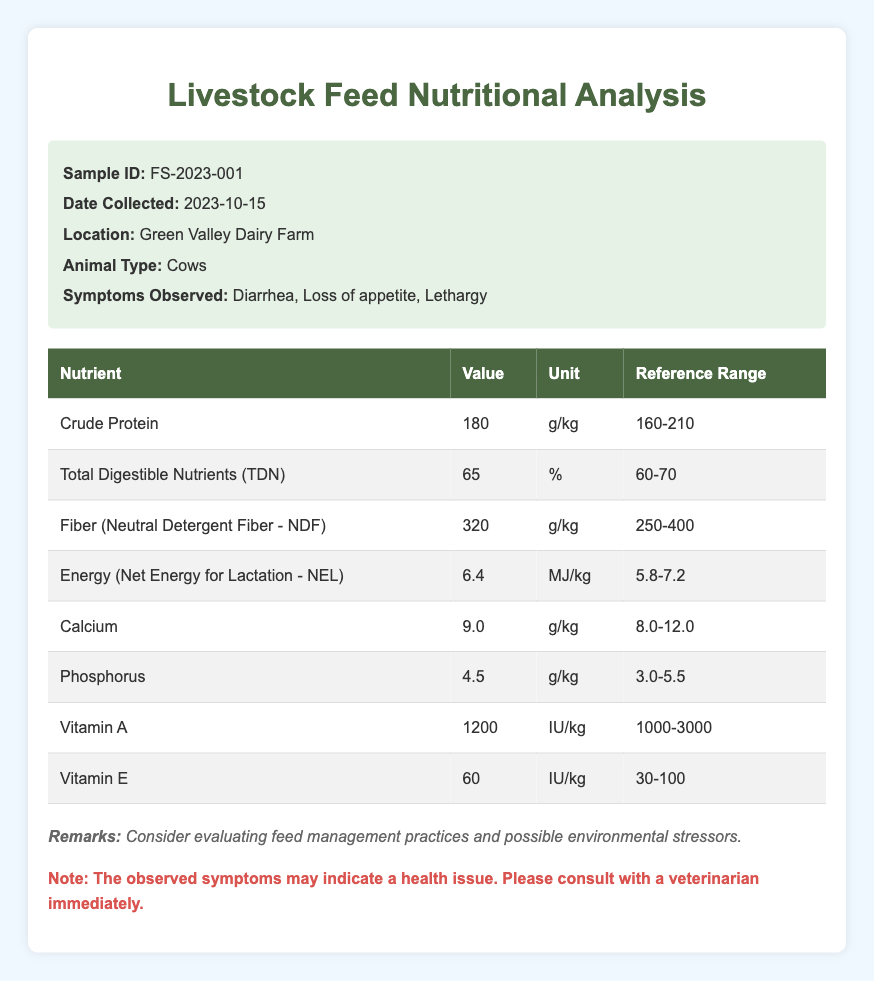What is the Crude Protein value in the feed sample? The table indicates that the Crude Protein value for the feed sample is listed under the "Nutritional Components," specifically for the nutrient "Crude Protein," where the value is 180 g/kg.
Answer: 180 g/kg What are the symptoms observed in the cows? According to the sample information section, the observed symptoms for the cows include "Diarrhea," "Loss of appetite," and "Lethargy."
Answer: Diarrhea, Loss of appetite, Lethargy Is the Total Digestible Nutrients (TDN) value within the acceptable reference range? The TDN value is given as 65%, which lies within the reference range of 60-70%. Since 65% is between the lower limit of 60% and the upper limit of 70%, it is indeed acceptable.
Answer: Yes What nutrient has the highest value in the analysis? To find the nutrient with the highest value, we need to compare all the values listed: Crude Protein 180 g/kg, TDN 65%, Fiber 320 g/kg, NEL 6.4 MJ/kg, Calcium 9.0 g/kg, Phosphorus 4.5 g/kg, Vitamin A 1200 IU/kg, and Vitamin E 60 IU/kg. Among these, Crude Protein, Fiber, and Calcium have the same unit (g/kg), making Fiber the highest at 320 g/kg when compared directly with other g/kg measurements.
Answer: Fiber 320 g/kg What is the average value of Calcium and Phosphorus in the feed sample? To calculate the average of Calcium and Phosphorus, we take their values: Calcium is 9.0 g/kg and Phosphorus is 4.5 g/kg. Adding them gives us 9.0 + 4.5 = 13.5 g/kg. Then we divide by 2 (since there are two components) to get the average: 13.5/2 = 6.75 g/kg.
Answer: 6.75 g/kg Is the Vitamin E value too low compared to its reference range? The Vitamin E value is 60 IU/kg, and the reference range given is 30-100 IU/kg. Since 60 IU/kg falls within this range, it is not considered too low.
Answer: No What is the range of Nutritional Components related to Energy (NEL)? In the table, the Energy (Net Energy for Lactation - NEL) value is found to be 6.4 MJ/kg, with a reference range of 5.8-7.2 MJ/kg. The range indicates that the value is acceptable, but if asked what the range of values is, we can state the reference range itself, which is 5.8 to 7.2 MJ/kg.
Answer: 5.8 to 7.2 MJ/kg How many nutritional components are above their lower limit in the reference range? We will look at each nutritional component: Crude Protein 180 g/kg (above 160), TDN 65% (above 60), Fiber 320 g/kg (above 250), NEL 6.4 MJ/kg (above 5.8), Calcium 9.0 g/kg (above 8.0), Phosphorus 4.5 g/kg (above 3.0), Vitamin A 1200 IU/kg (above 1000), and Vitamin E 60 IU/kg (above 30). All components are above their lower reference limits, giving us a total of 8.
Answer: 8 